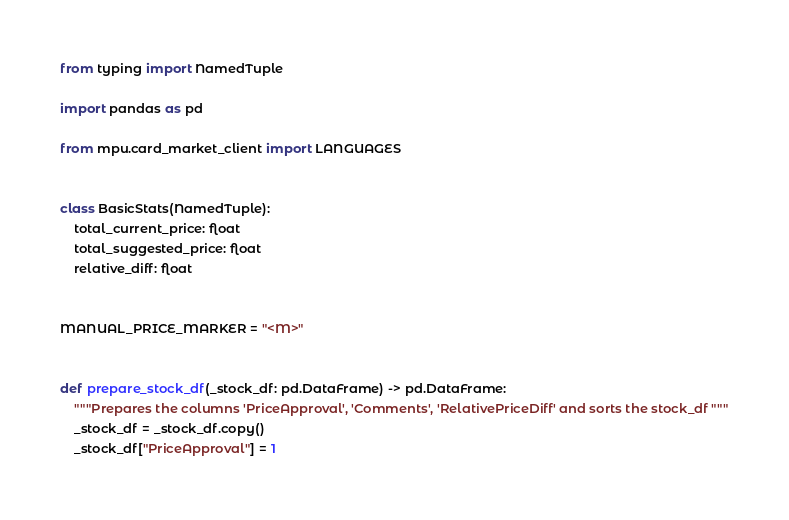<code> <loc_0><loc_0><loc_500><loc_500><_Python_>from typing import NamedTuple

import pandas as pd

from mpu.card_market_client import LANGUAGES


class BasicStats(NamedTuple):
    total_current_price: float
    total_suggested_price: float
    relative_diff: float


MANUAL_PRICE_MARKER = "<M>"


def prepare_stock_df(_stock_df: pd.DataFrame) -> pd.DataFrame:
    """Prepares the columns 'PriceApproval', 'Comments', 'RelativePriceDiff' and sorts the stock_df """
    _stock_df = _stock_df.copy()
    _stock_df["PriceApproval"] = 1</code> 